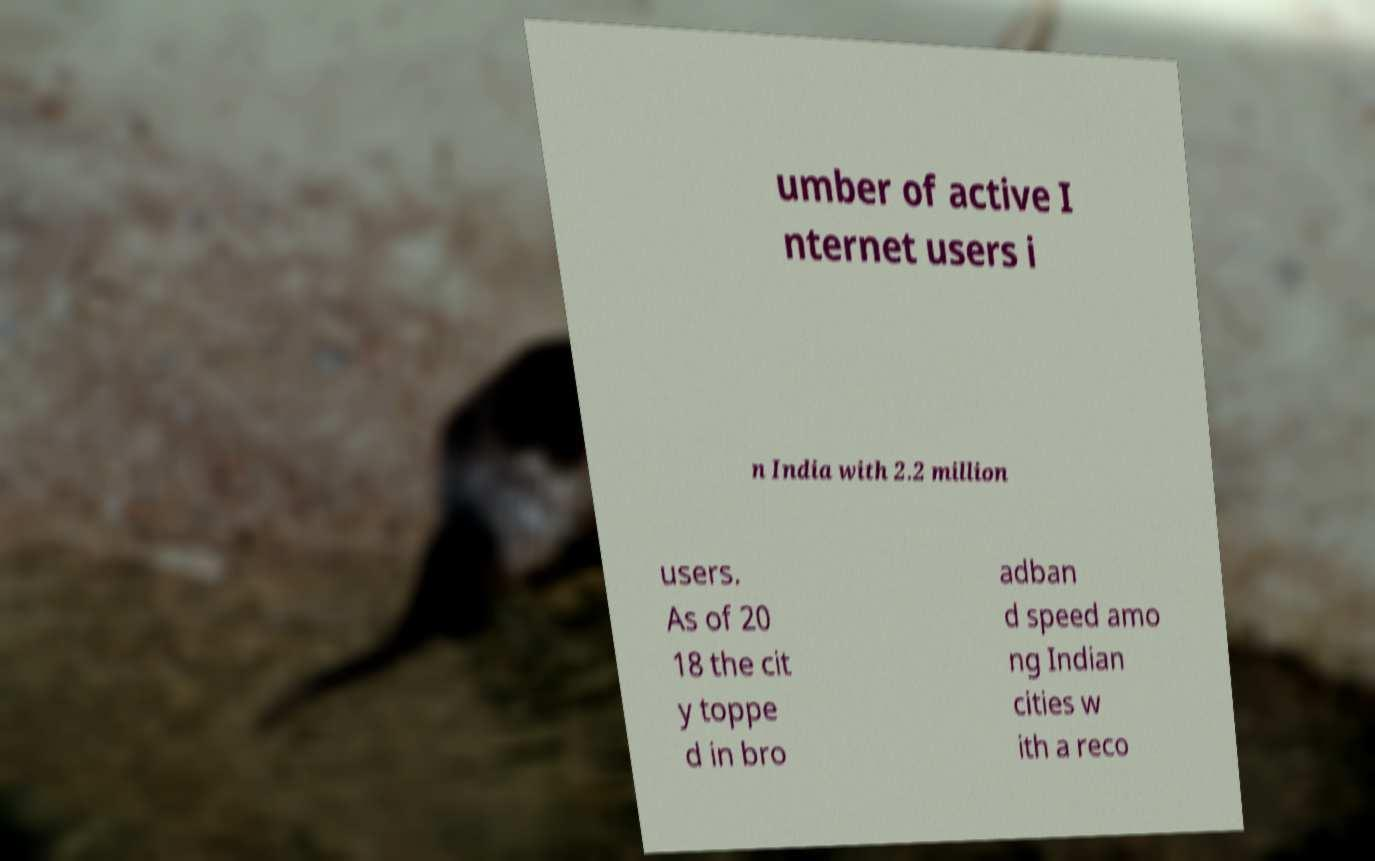Can you read and provide the text displayed in the image?This photo seems to have some interesting text. Can you extract and type it out for me? umber of active I nternet users i n India with 2.2 million users. As of 20 18 the cit y toppe d in bro adban d speed amo ng Indian cities w ith a reco 